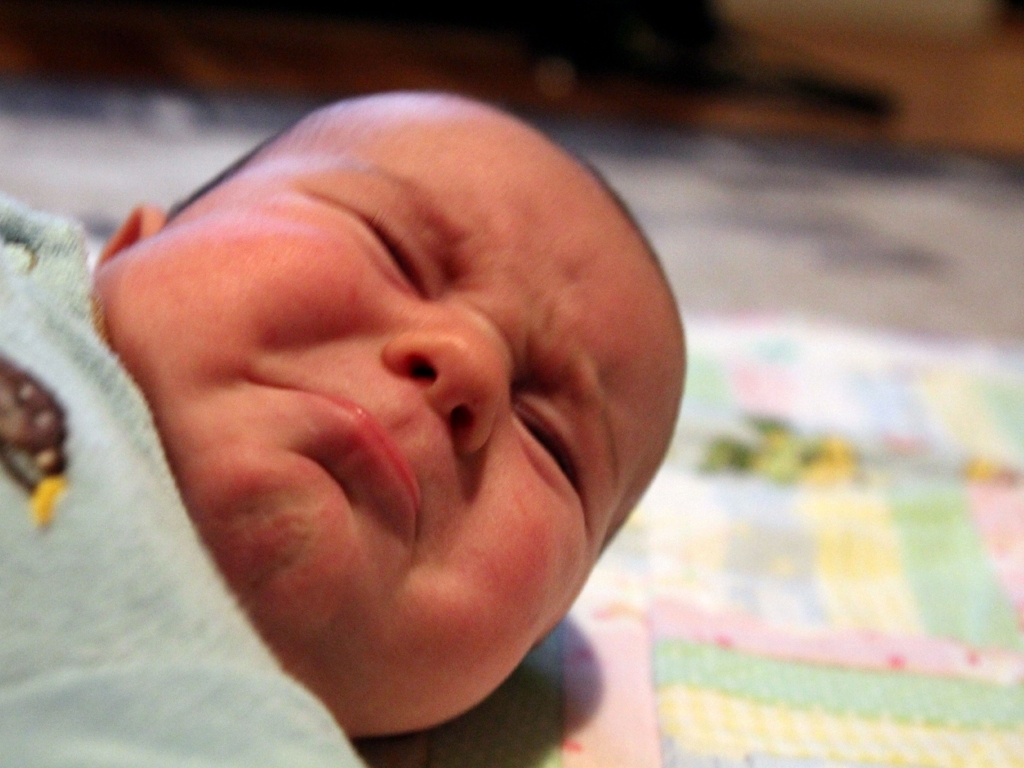What emotions does the baby seem to be expressing? The baby appears to be exhibiting a facial expression that could be interpreted as a mix of discomfort and sleepiness, often typical for newborns adjusting to their new surroundings. 